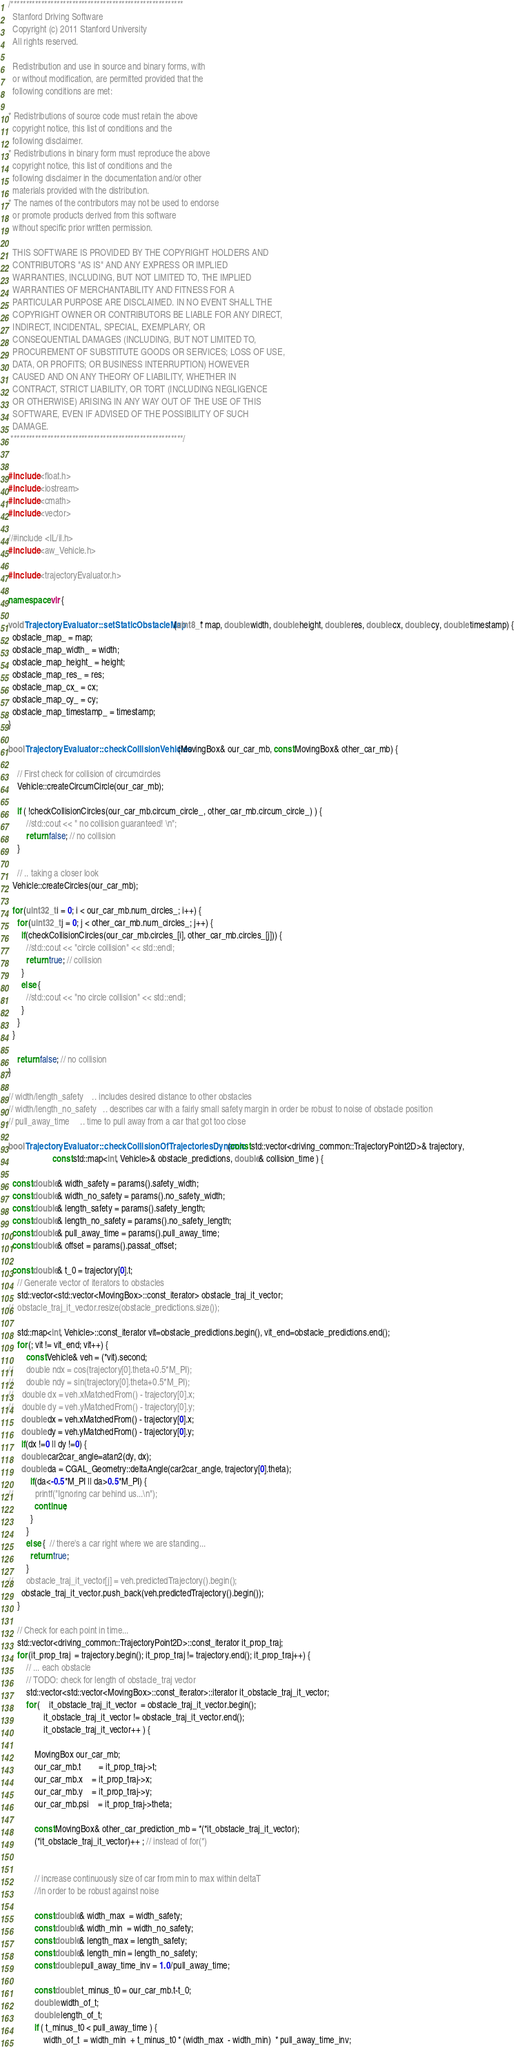Convert code to text. <code><loc_0><loc_0><loc_500><loc_500><_C++_>/********************************************************
  Stanford Driving Software
  Copyright (c) 2011 Stanford University
  All rights reserved.

  Redistribution and use in source and binary forms, with 
  or without modification, are permitted provided that the 
  following conditions are met:

* Redistributions of source code must retain the above 
  copyright notice, this list of conditions and the 
  following disclaimer.
* Redistributions in binary form must reproduce the above
  copyright notice, this list of conditions and the 
  following disclaimer in the documentation and/or other
  materials provided with the distribution.
* The names of the contributors may not be used to endorse
  or promote products derived from this software
  without specific prior written permission.

  THIS SOFTWARE IS PROVIDED BY THE COPYRIGHT HOLDERS AND
  CONTRIBUTORS "AS IS" AND ANY EXPRESS OR IMPLIED
  WARRANTIES, INCLUDING, BUT NOT LIMITED TO, THE IMPLIED
  WARRANTIES OF MERCHANTABILITY AND FITNESS FOR A
  PARTICULAR PURPOSE ARE DISCLAIMED. IN NO EVENT SHALL THE
  COPYRIGHT OWNER OR CONTRIBUTORS BE LIABLE FOR ANY DIRECT, 
  INDIRECT, INCIDENTAL, SPECIAL, EXEMPLARY, OR 
  CONSEQUENTIAL DAMAGES (INCLUDING, BUT NOT LIMITED TO, 
  PROCUREMENT OF SUBSTITUTE GOODS OR SERVICES; LOSS OF USE,
  DATA, OR PROFITS; OR BUSINESS INTERRUPTION) HOWEVER
  CAUSED AND ON ANY THEORY OF LIABILITY, WHETHER IN 
  CONTRACT, STRICT LIABILITY, OR TORT (INCLUDING NEGLIGENCE 
  OR OTHERWISE) ARISING IN ANY WAY OUT OF THE USE OF THIS
  SOFTWARE, EVEN IF ADVISED OF THE POSSIBILITY OF SUCH
  DAMAGE.
 ********************************************************/


#include <float.h>
#include <iostream>
#include <cmath>
#include <vector>

//#include <IL/il.h>
#include <aw_Vehicle.h>

#include <trajectoryEvaluator.h>

namespace vlr {

void TrajectoryEvaluator::setStaticObstacleMap(uint8_t* map, double width, double height, double res, double cx, double cy, double timestamp) {
  obstacle_map_ = map;
  obstacle_map_width_ = width;
  obstacle_map_height_ = height;
  obstacle_map_res_ = res;
  obstacle_map_cx_ = cx;
  obstacle_map_cy_ = cy;
  obstacle_map_timestamp_ = timestamp;
}

bool TrajectoryEvaluator::checkCollisionVehicles(MovingBox& our_car_mb, const MovingBox& other_car_mb) {

	// First check for collision of circumcircles
	Vehicle::createCircumCircle(our_car_mb);

	if ( !checkCollisionCircles(our_car_mb.circum_circle_, other_car_mb.circum_circle_) ) {
		//std::cout << " no collision guaranteed! \n";
		return false; // no collision
	}

    // .. taking a closer look
  Vehicle::createCircles(our_car_mb);

  for (uint32_t i = 0; i < our_car_mb.num_circles_; i++) {
    for (uint32_t j = 0; j < other_car_mb.num_circles_; j++) {
      if(checkCollisionCircles(our_car_mb.circles_[i], other_car_mb.circles_[j])) {
        //std::cout << "circle collision" << std::endl;
        return true; // collision
      }
      else {
        //std::cout << "no circle collision" << std::endl;
      }
    }
  }

	return false; // no collision
}

// width/length_safety    .. includes desired distance to other obstacles
// width/length_no_safety   .. describes car with a fairly small safety margin in order be robust to noise of obstacle position
// pull_away_time     .. time to pull away from a car that got too close

bool TrajectoryEvaluator::checkCollisionOfTrajectoriesDynamic(const std::vector<driving_common::TrajectoryPoint2D>& trajectory,
					const std::map<int, Vehicle>& obstacle_predictions, double& collision_time ) {

  const double& width_safety = params().safety_width;
  const double& width_no_safety = params().no_safety_width;
  const double& length_safety = params().safety_length;
  const double& length_no_safety = params().no_safety_length;
  const double& pull_away_time = params().pull_away_time;
  const double& offset = params().passat_offset;

  const double& t_0 = trajectory[0].t;
	// Generate vector of iterators to obstacles
	std::vector<std::vector<MovingBox>::const_iterator> obstacle_traj_it_vector;
//	obstacle_traj_it_vector.resize(obstacle_predictions.size());

	std::map<int, Vehicle>::const_iterator vit=obstacle_predictions.begin(), vit_end=obstacle_predictions.end();
	for (; vit != vit_end; vit++) {
		const Vehicle& veh = (*vit).second;
//		double ndx = cos(trajectory[0].theta+0.5*M_PI);
//		double ndy = sin(trajectory[0].theta+0.5*M_PI);
//    double dx = veh.xMatchedFrom() - trajectory[0].x;
//    double dy = veh.yMatchedFrom() - trajectory[0].y;
      double dx = veh.xMatchedFrom() - trajectory[0].x;
      double dy = veh.yMatchedFrom() - trajectory[0].y;
      if(dx !=0 || dy !=0) {
      double car2car_angle=atan2(dy, dx);
      double da = CGAL_Geometry::deltaAngle(car2car_angle, trajectory[0].theta);
		  if(da<-0.5*M_PI || da>0.5*M_PI) {
//		    printf("Ignoring car behind us...\n");
		    continue;
		  }
		}
		else {  // there's a car right where we are standing...
		  return true;
		}
//      obstacle_traj_it_vector[j] = veh.predictedTrajectory().begin();
      obstacle_traj_it_vector.push_back(veh.predictedTrajectory().begin());
	}

	// Check for each point in time...
	std::vector<driving_common::TrajectoryPoint2D>::const_iterator it_prop_traj;
	for (it_prop_traj  = trajectory.begin(); it_prop_traj != trajectory.end(); it_prop_traj++) {
		// ... each obstacle
		// TODO: check for length of obstacle_traj vector
		std::vector<std::vector<MovingBox>::const_iterator>::iterator it_obstacle_traj_it_vector;
		for ( 	it_obstacle_traj_it_vector  = obstacle_traj_it_vector.begin();
				it_obstacle_traj_it_vector != obstacle_traj_it_vector.end();
				it_obstacle_traj_it_vector++ ) {

			MovingBox our_car_mb;
			our_car_mb.t		= it_prop_traj->t;
			our_car_mb.x 	= it_prop_traj->x;
			our_car_mb.y 	= it_prop_traj->y;
			our_car_mb.psi 	= it_prop_traj->theta;

			const MovingBox& other_car_prediction_mb = *(*it_obstacle_traj_it_vector);
			(*it_obstacle_traj_it_vector)++ ; // instead of for(*)


			// increase continuously size of car from min to max within deltaT
			//in order to be robust against noise

			const double& width_max  = width_safety;
			const double& width_min  = width_no_safety;
			const double& length_max = length_safety;
			const double& length_min = length_no_safety;
			const double pull_away_time_inv = 1.0/pull_away_time;

			const double t_minus_t0 = our_car_mb.t-t_0;
			double width_of_t;
			double length_of_t;
			if ( t_minus_t0 < pull_away_time ) {
				width_of_t  = width_min  + t_minus_t0 * (width_max  - width_min)  * pull_away_time_inv;</code> 